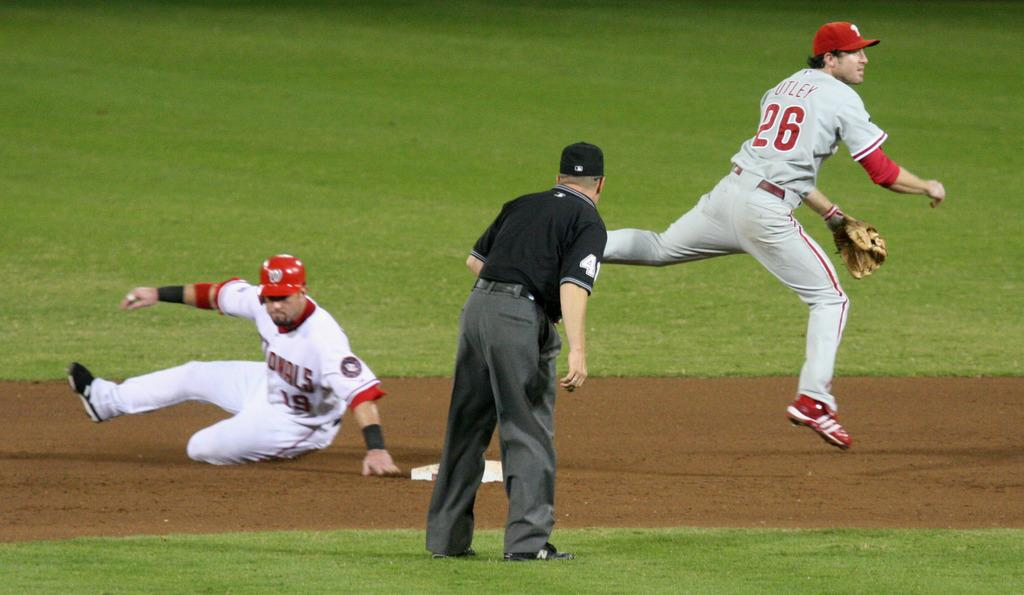<image>
Provide a brief description of the given image. a baseball player named chase utley throwing a ball 